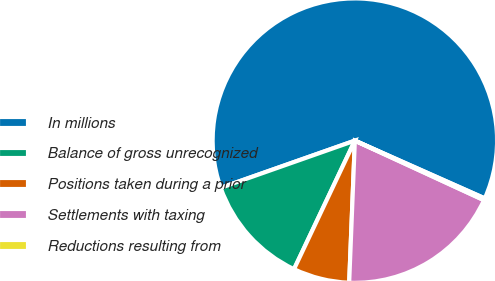<chart> <loc_0><loc_0><loc_500><loc_500><pie_chart><fcel>In millions<fcel>Balance of gross unrecognized<fcel>Positions taken during a prior<fcel>Settlements with taxing<fcel>Reductions resulting from<nl><fcel>62.04%<fcel>12.58%<fcel>6.4%<fcel>18.76%<fcel>0.22%<nl></chart> 